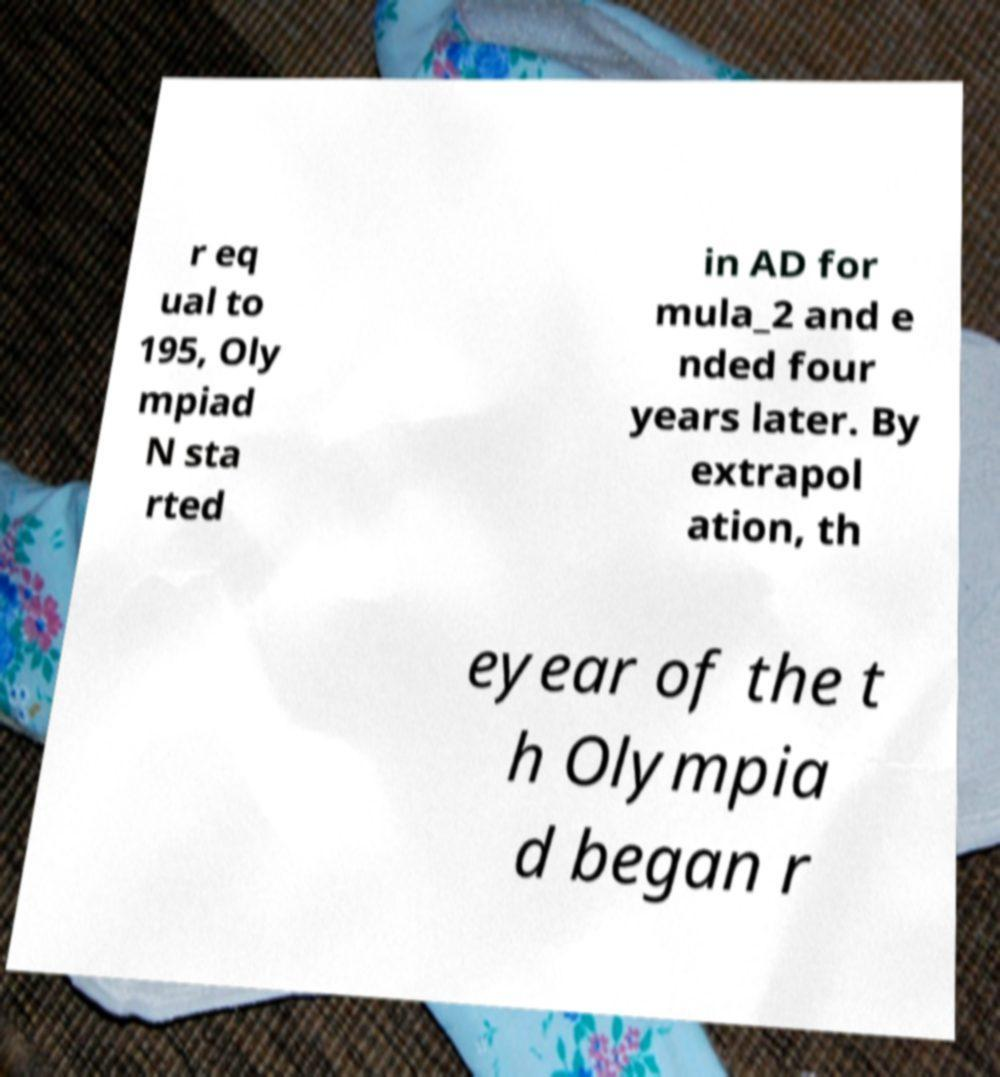Could you extract and type out the text from this image? r eq ual to 195, Oly mpiad N sta rted in AD for mula_2 and e nded four years later. By extrapol ation, th eyear of the t h Olympia d began r 